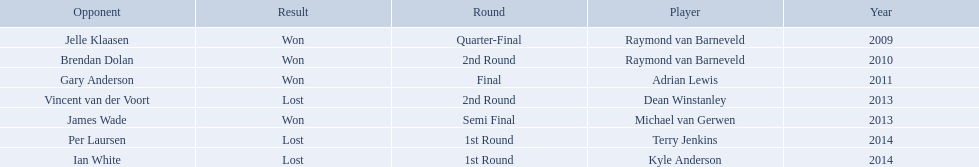Who are the players at the pdc world darts championship? Raymond van Barneveld, Raymond van Barneveld, Adrian Lewis, Dean Winstanley, Michael van Gerwen, Terry Jenkins, Kyle Anderson. When did kyle anderson lose? 2014. Which other players lost in 2014? Terry Jenkins. Did terry jenkins win in 2014? Terry Jenkins, Lost. If terry jenkins lost who won? Per Laursen. Who were the players in 2014? Terry Jenkins, Kyle Anderson. Did they win or lose? Per Laursen. 